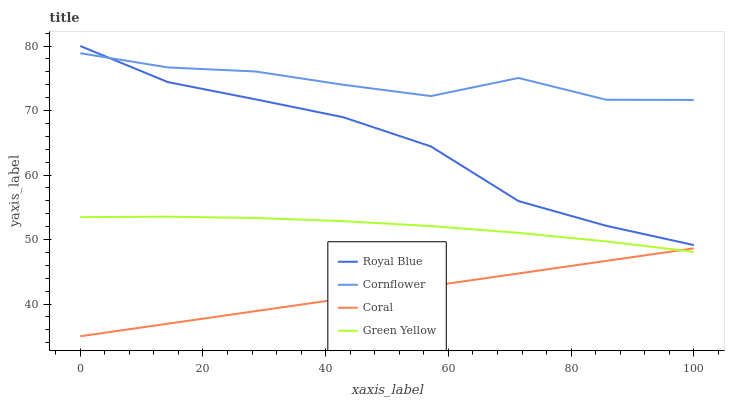Does Coral have the minimum area under the curve?
Answer yes or no. Yes. Does Cornflower have the maximum area under the curve?
Answer yes or no. Yes. Does Green Yellow have the minimum area under the curve?
Answer yes or no. No. Does Green Yellow have the maximum area under the curve?
Answer yes or no. No. Is Coral the smoothest?
Answer yes or no. Yes. Is Cornflower the roughest?
Answer yes or no. Yes. Is Green Yellow the smoothest?
Answer yes or no. No. Is Green Yellow the roughest?
Answer yes or no. No. Does Coral have the lowest value?
Answer yes or no. Yes. Does Green Yellow have the lowest value?
Answer yes or no. No. Does Royal Blue have the highest value?
Answer yes or no. Yes. Does Green Yellow have the highest value?
Answer yes or no. No. Is Green Yellow less than Royal Blue?
Answer yes or no. Yes. Is Royal Blue greater than Green Yellow?
Answer yes or no. Yes. Does Royal Blue intersect Cornflower?
Answer yes or no. Yes. Is Royal Blue less than Cornflower?
Answer yes or no. No. Is Royal Blue greater than Cornflower?
Answer yes or no. No. Does Green Yellow intersect Royal Blue?
Answer yes or no. No. 